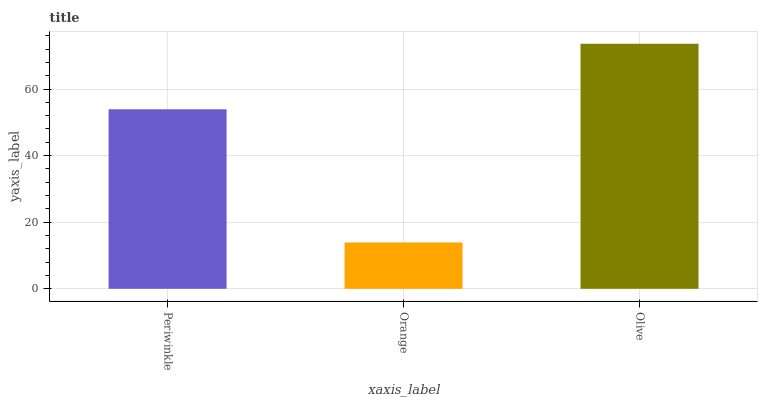Is Olive the minimum?
Answer yes or no. No. Is Orange the maximum?
Answer yes or no. No. Is Olive greater than Orange?
Answer yes or no. Yes. Is Orange less than Olive?
Answer yes or no. Yes. Is Orange greater than Olive?
Answer yes or no. No. Is Olive less than Orange?
Answer yes or no. No. Is Periwinkle the high median?
Answer yes or no. Yes. Is Periwinkle the low median?
Answer yes or no. Yes. Is Orange the high median?
Answer yes or no. No. Is Orange the low median?
Answer yes or no. No. 